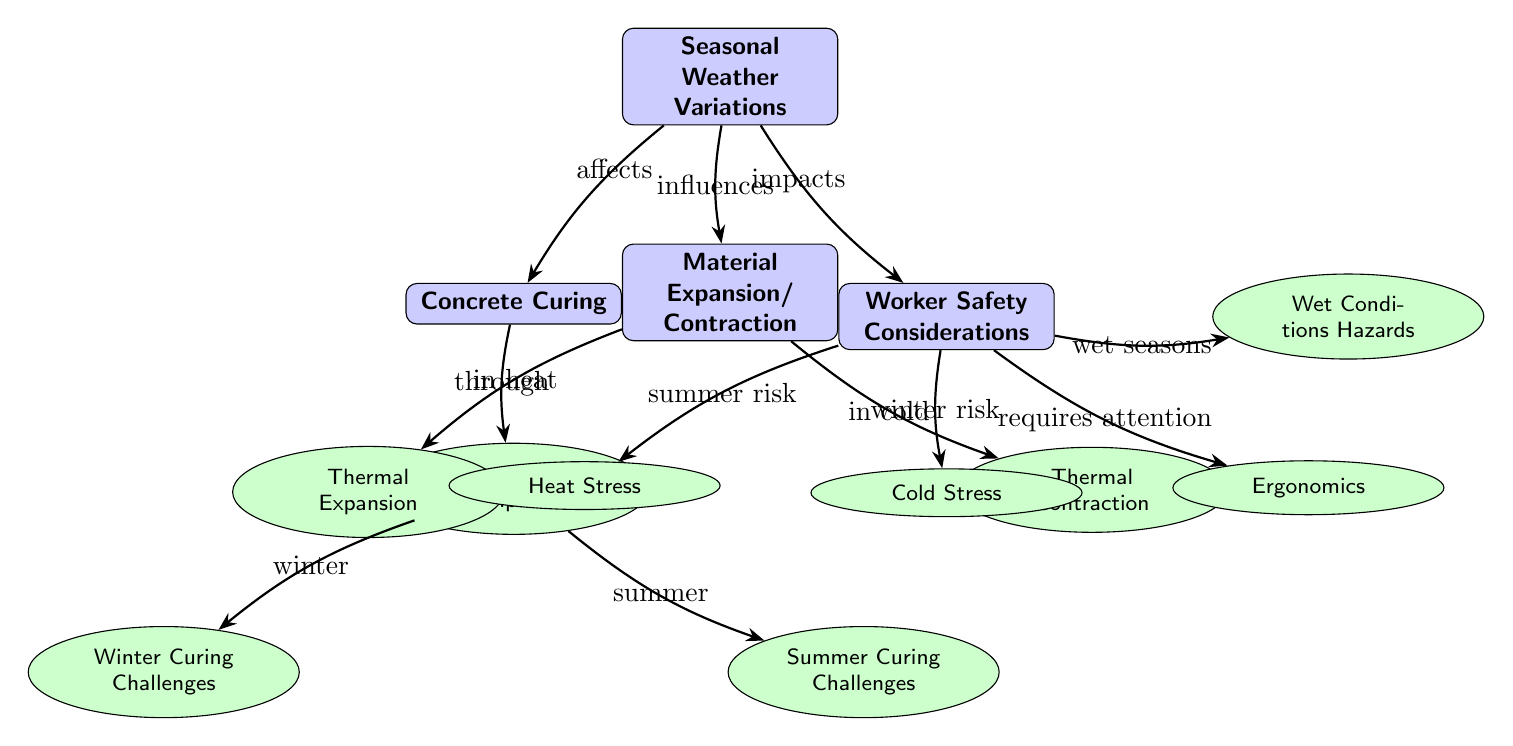What is the main topic of the diagram? The diagram highlights how seasonal weather variations influence several aspects of construction projects, showing the relationships between weather effects, concrete curing, material behavior, and worker safety.
Answer: Seasonal Weather Variations What two challenges are associated with concrete curing? The diagram indicates that concrete curing has specific challenges in both winter and summer, which are pointed out as distinct sub-nodes.
Answer: Winter Curing Challenges, Summer Curing Challenges Which node describes the impact of cold on materials? The node dedicated to this impact specifically discusses how materials behave in cold weather, leading to thermal contraction.
Answer: Thermal Contraction How many worker safety considerations are listed in the diagram? By counting the nodes connected to the "Worker Safety Considerations" main node, we find four specific sub-nodes indicating various safety elements.
Answer: Four What is the effect of high temperatures according to the diagram? The diagram explains that high temperatures lead to thermal expansion of materials, which could impact their performance on site.
Answer: Thermal Expansion In what season might heat stress become a concern for workers? The diagram shows a connection that suggests heat stress becomes relevant during summer risk considerations specifically.
Answer: Summer What safety consideration does wet conditions relate to? Wet conditions in the diagram are associated with hazards that workers may face, specifically linked under worker safety.
Answer: Wet Conditions Hazards What two types of weather variations are explicitly mentioned concerning worker safety? The diagram points out both heat stress during hot months and cold stress during chilly periods as critical considerations for worker safety.
Answer: Heat Stress, Cold Stress What relationship does seasonal weather have with material expansion? The diagram indicates that seasonal weather influences the behavior of materials, specifically their expansion in heat and contraction in cold conditions.
Answer: Influences 